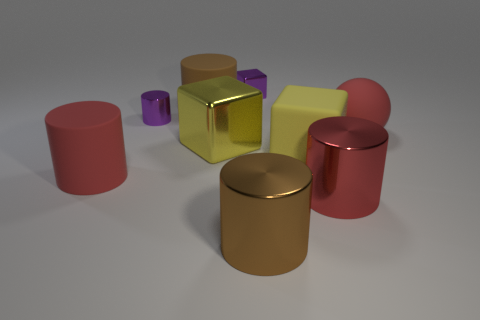There is a small metal object that is to the right of the yellow shiny block; is its color the same as the ball? no 